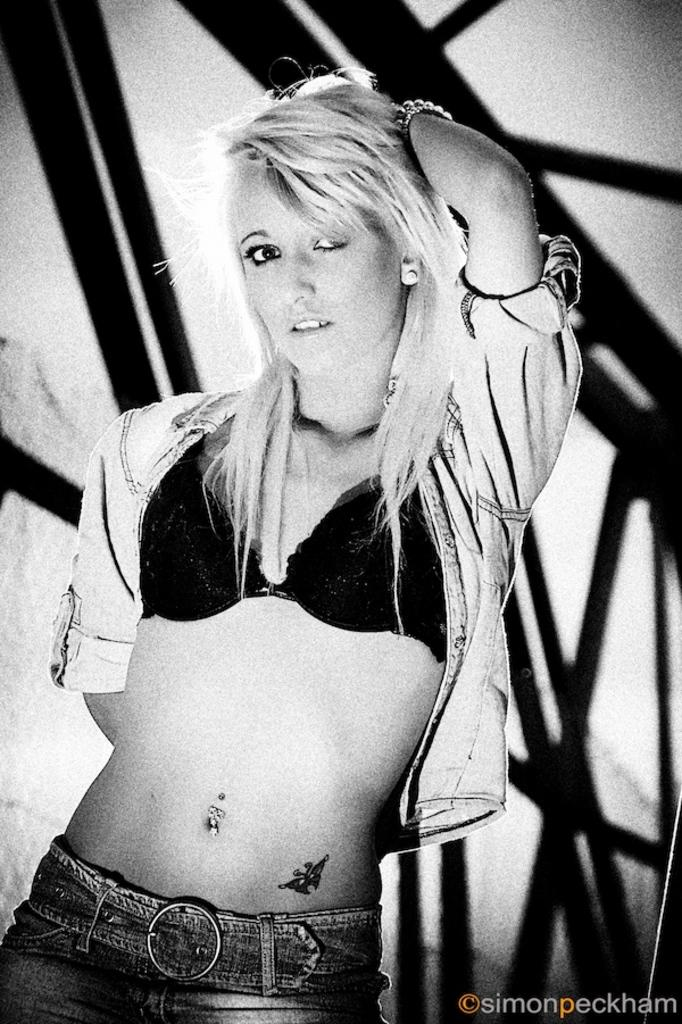What is the main subject of the image? There is a person in the image. Can you describe the person's attire? The person is wearing a dress. What can be seen in the background of the image? There are metal rods in the background of the image. What is the color scheme of the image? The image is black and white. What type of record can be seen spinning on the person's head in the image? There is no record present in the image; it features a person wearing a dress with metal rods in the background. Can you describe the jellyfish swimming near the person in the image? There are no jellyfish present in the image. 